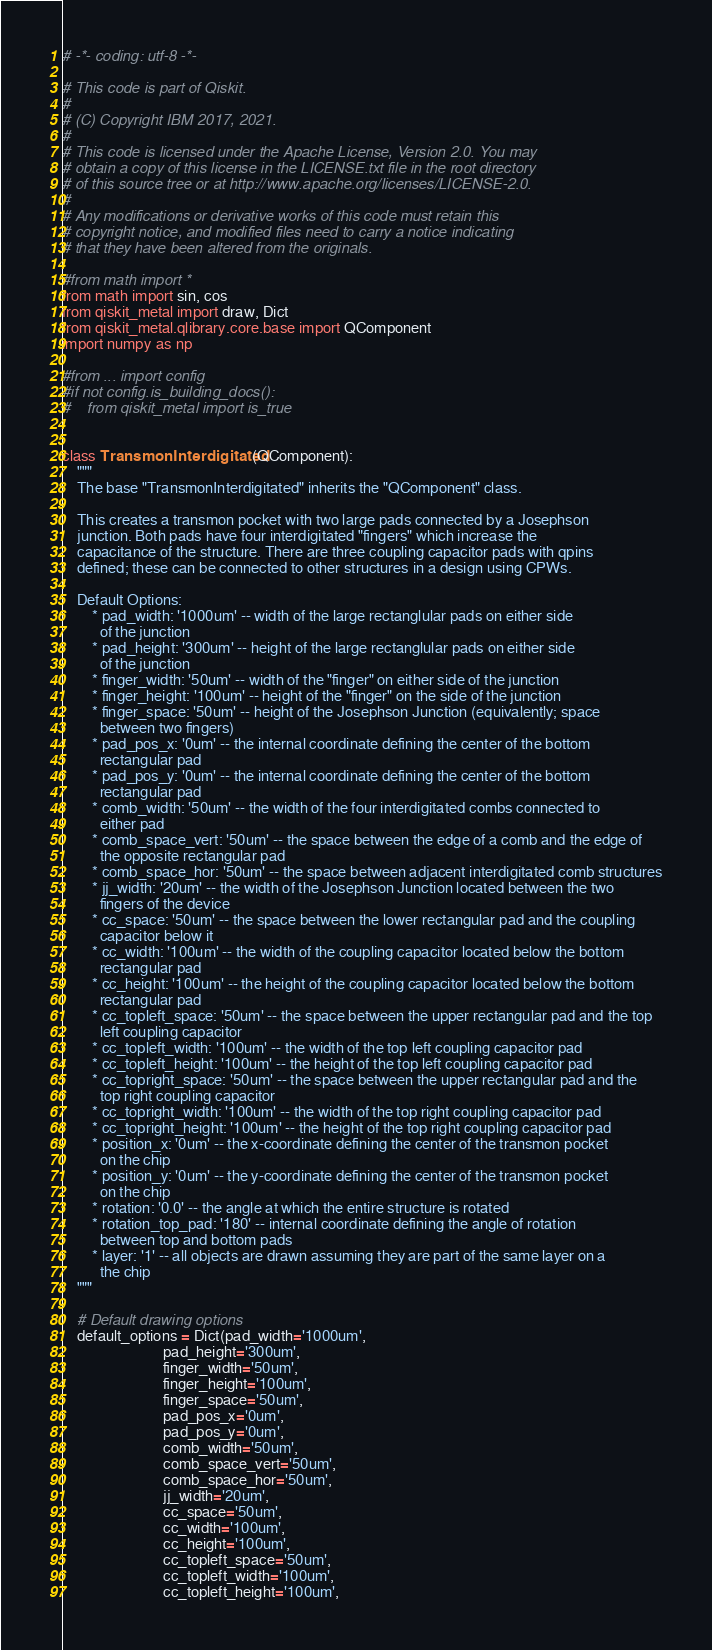Convert code to text. <code><loc_0><loc_0><loc_500><loc_500><_Python_># -*- coding: utf-8 -*-

# This code is part of Qiskit.
#
# (C) Copyright IBM 2017, 2021.
#
# This code is licensed under the Apache License, Version 2.0. You may
# obtain a copy of this license in the LICENSE.txt file in the root directory
# of this source tree or at http://www.apache.org/licenses/LICENSE-2.0.
#
# Any modifications or derivative works of this code must retain this
# copyright notice, and modified files need to carry a notice indicating
# that they have been altered from the originals.

#from math import *
from math import sin, cos
from qiskit_metal import draw, Dict
from qiskit_metal.qlibrary.core.base import QComponent
import numpy as np

#from ... import config
#if not config.is_building_docs():
#    from qiskit_metal import is_true


class TransmonInterdigitated(QComponent):
    """
    The base "TransmonInterdigitated" inherits the "QComponent" class.

    This creates a transmon pocket with two large pads connected by a Josephson
    junction. Both pads have four interdigitated "fingers" which increase the
    capacitance of the structure. There are three coupling capacitor pads with qpins
    defined; these can be connected to other structures in a design using CPWs.

    Default Options:
        * pad_width: '1000um' -- width of the large rectanglular pads on either side
          of the junction
        * pad_height: '300um' -- height of the large rectanglular pads on either side
          of the junction
        * finger_width: '50um' -- width of the "finger" on either side of the junction
        * finger_height: '100um' -- height of the "finger" on the side of the junction
        * finger_space: '50um' -- height of the Josephson Junction (equivalently; space
          between two fingers)
        * pad_pos_x: '0um' -- the internal coordinate defining the center of the bottom
          rectangular pad
        * pad_pos_y: '0um' -- the internal coordinate defining the center of the bottom
          rectangular pad
        * comb_width: '50um' -- the width of the four interdigitated combs connected to
          either pad
        * comb_space_vert: '50um' -- the space between the edge of a comb and the edge of
          the opposite rectangular pad
        * comb_space_hor: '50um' -- the space between adjacent interdigitated comb structures
        * jj_width: '20um' -- the width of the Josephson Junction located between the two
          fingers of the device
        * cc_space: '50um' -- the space between the lower rectangular pad and the coupling
          capacitor below it
        * cc_width: '100um' -- the width of the coupling capacitor located below the bottom
          rectangular pad
        * cc_height: '100um' -- the height of the coupling capacitor located below the bottom
          rectangular pad
        * cc_topleft_space: '50um' -- the space between the upper rectangular pad and the top
          left coupling capacitor
        * cc_topleft_width: '100um' -- the width of the top left coupling capacitor pad
        * cc_topleft_height: '100um' -- the height of the top left coupling capacitor pad
        * cc_topright_space: '50um' -- the space between the upper rectangular pad and the
          top right coupling capacitor
        * cc_topright_width: '100um' -- the width of the top right coupling capacitor pad
        * cc_topright_height: '100um' -- the height of the top right coupling capacitor pad
        * position_x: '0um' -- the x-coordinate defining the center of the transmon pocket
          on the chip
        * position_y: '0um' -- the y-coordinate defining the center of the transmon pocket
          on the chip
        * rotation: '0.0' -- the angle at which the entire structure is rotated
        * rotation_top_pad: '180' -- internal coordinate defining the angle of rotation
          between top and bottom pads
        * layer: '1' -- all objects are drawn assuming they are part of the same layer on a
          the chip
    """

    # Default drawing options
    default_options = Dict(pad_width='1000um',
                           pad_height='300um',
                           finger_width='50um',
                           finger_height='100um',
                           finger_space='50um',
                           pad_pos_x='0um',
                           pad_pos_y='0um',
                           comb_width='50um',
                           comb_space_vert='50um',
                           comb_space_hor='50um',
                           jj_width='20um',
                           cc_space='50um',
                           cc_width='100um',
                           cc_height='100um',
                           cc_topleft_space='50um',
                           cc_topleft_width='100um',
                           cc_topleft_height='100um',</code> 